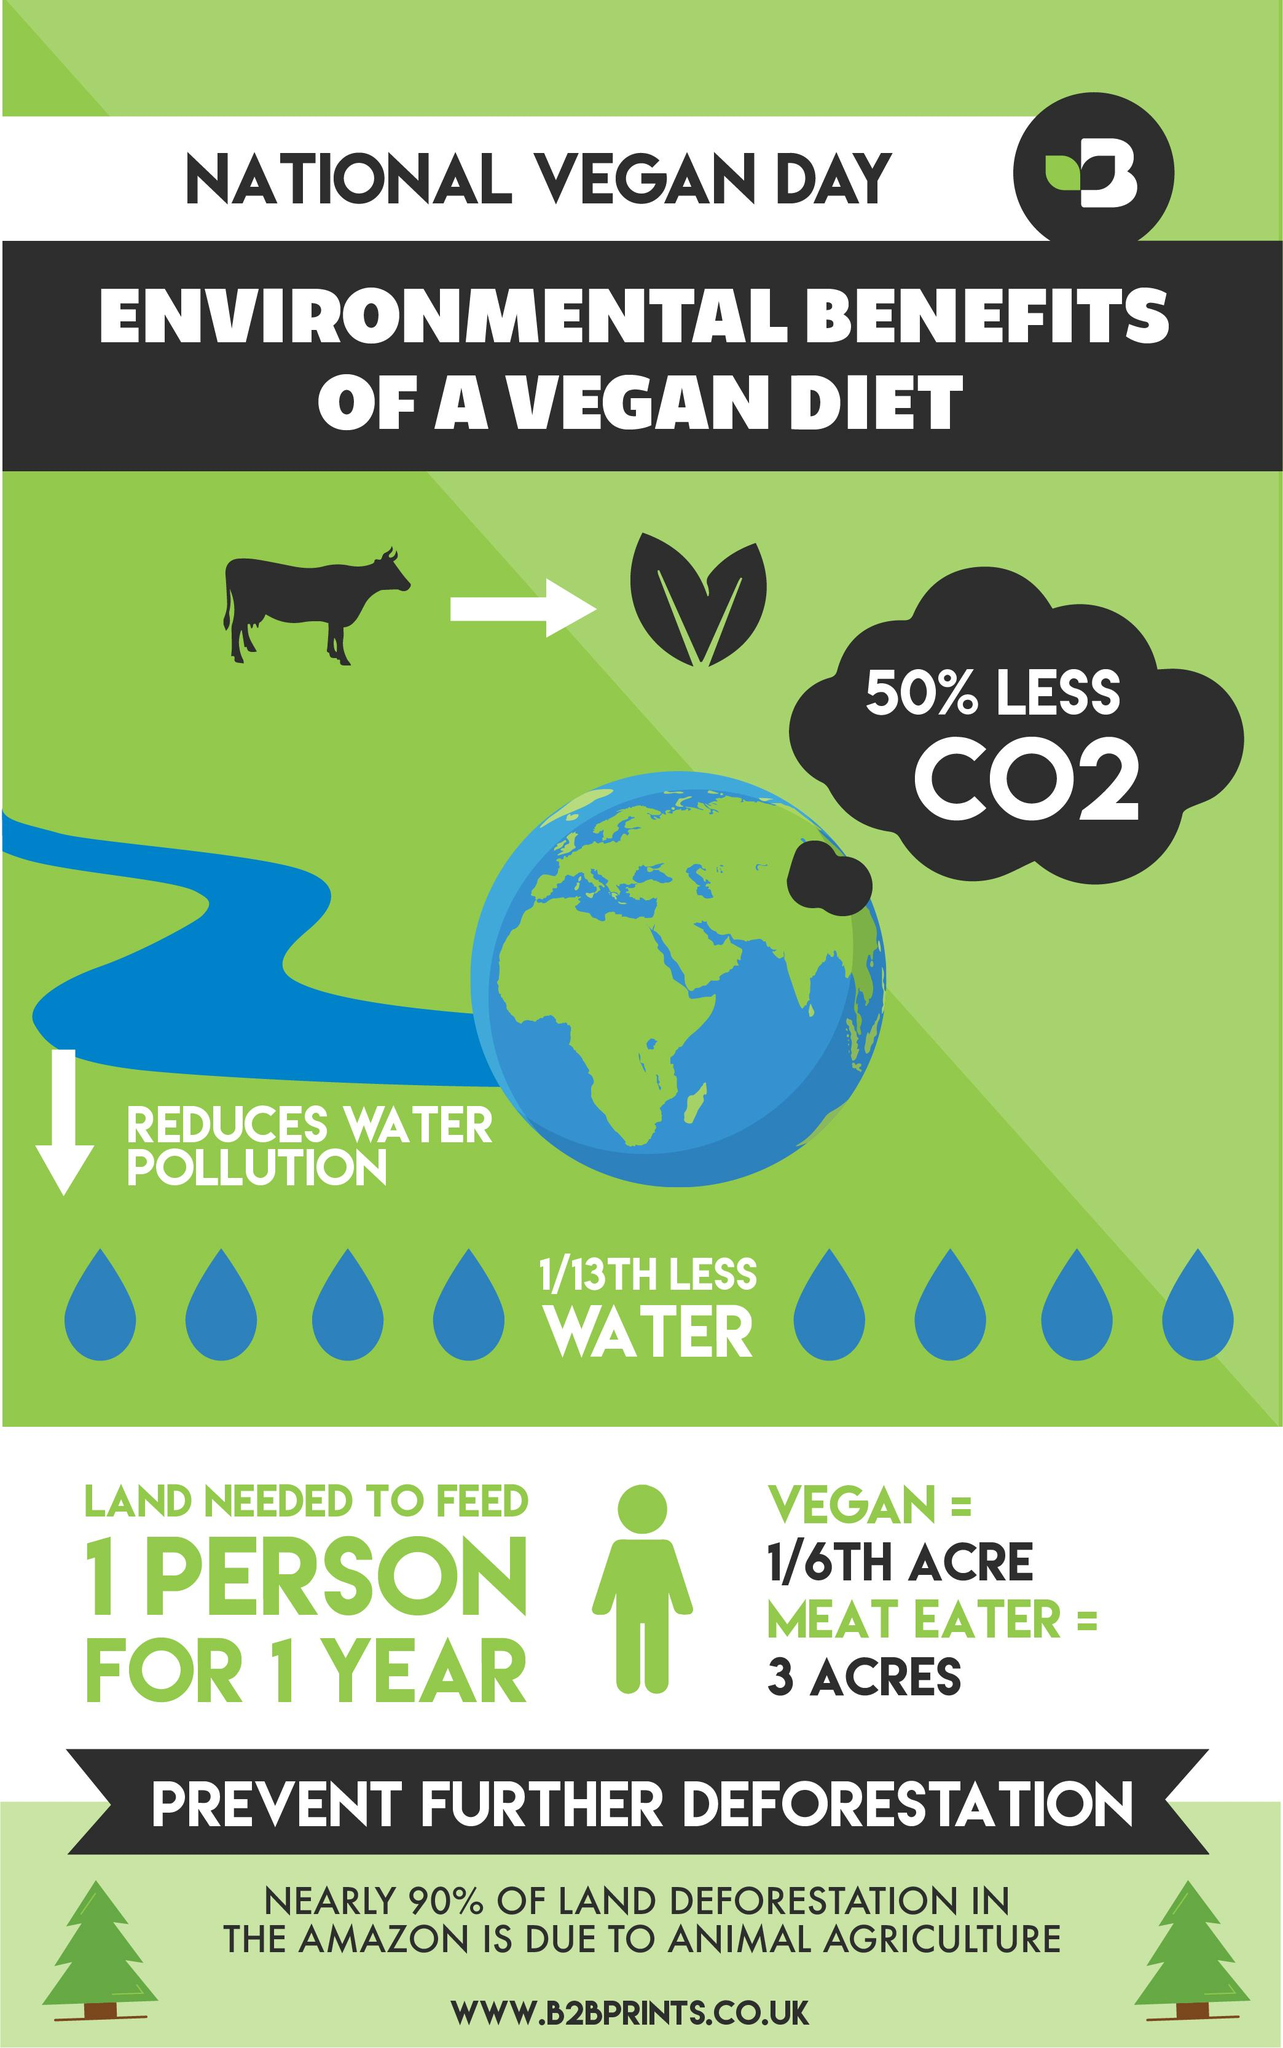Draw attention to some important aspects in this diagram. The amount of land needed to feed a vegan is 6,969.6 square feet. 